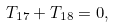<formula> <loc_0><loc_0><loc_500><loc_500>T _ { 1 7 } + T _ { 1 8 } = 0 ,</formula> 